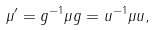<formula> <loc_0><loc_0><loc_500><loc_500>\mu ^ { \prime } = g ^ { - 1 } \mu g = u ^ { - 1 } \mu u ,</formula> 